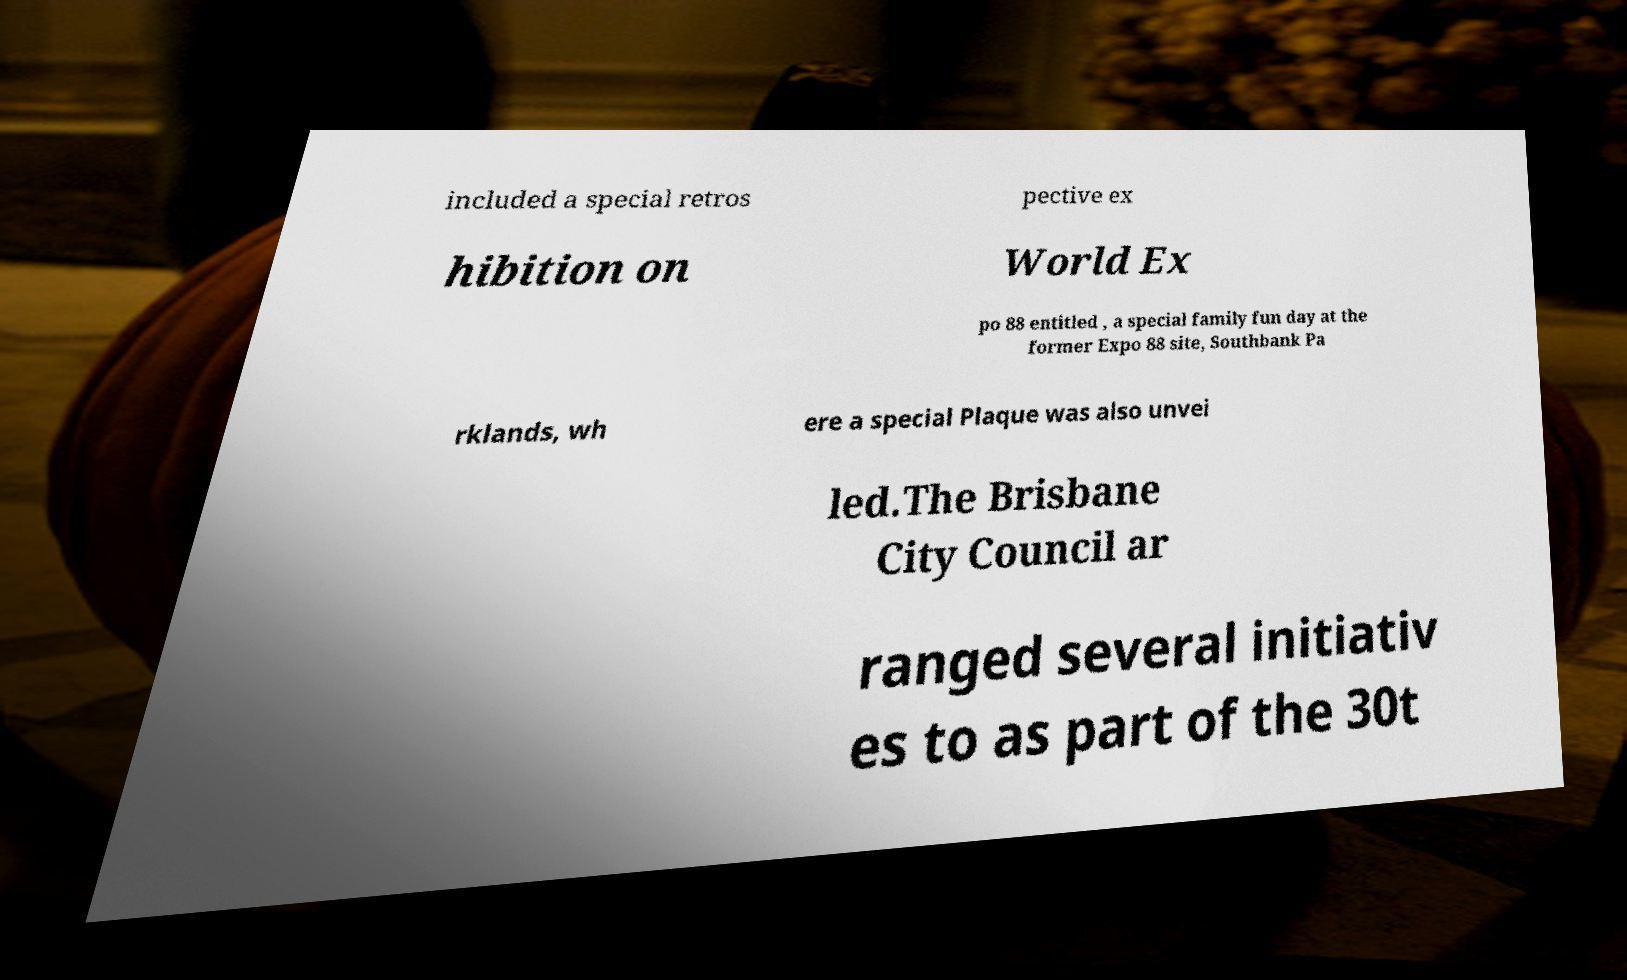Please read and relay the text visible in this image. What does it say? included a special retros pective ex hibition on World Ex po 88 entitled , a special family fun day at the former Expo 88 site, Southbank Pa rklands, wh ere a special Plaque was also unvei led.The Brisbane City Council ar ranged several initiativ es to as part of the 30t 